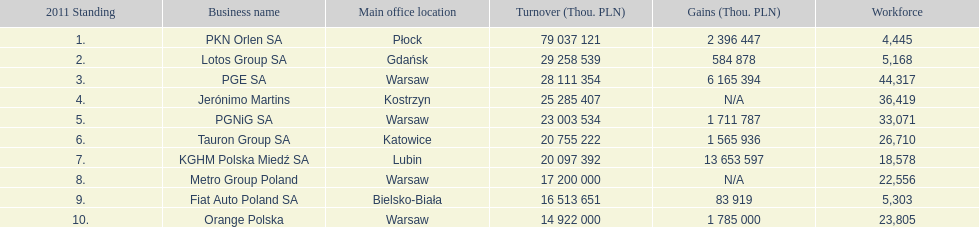What is the difference in employees for rank 1 and rank 3? 39,872 employees. 